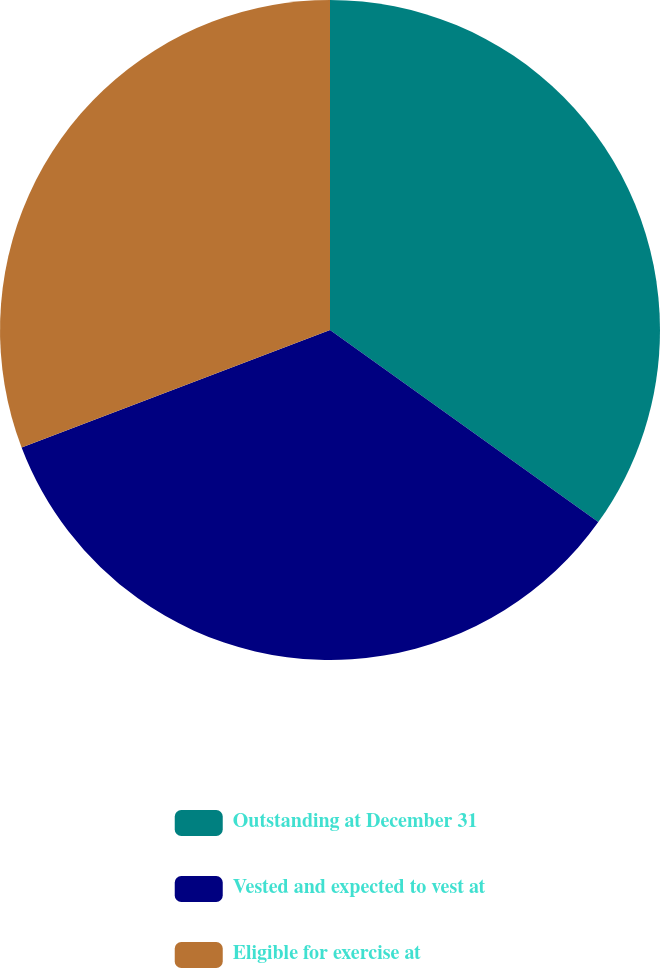Convert chart to OTSL. <chart><loc_0><loc_0><loc_500><loc_500><pie_chart><fcel>Outstanding at December 31<fcel>Vested and expected to vest at<fcel>Eligible for exercise at<nl><fcel>34.89%<fcel>34.32%<fcel>30.79%<nl></chart> 